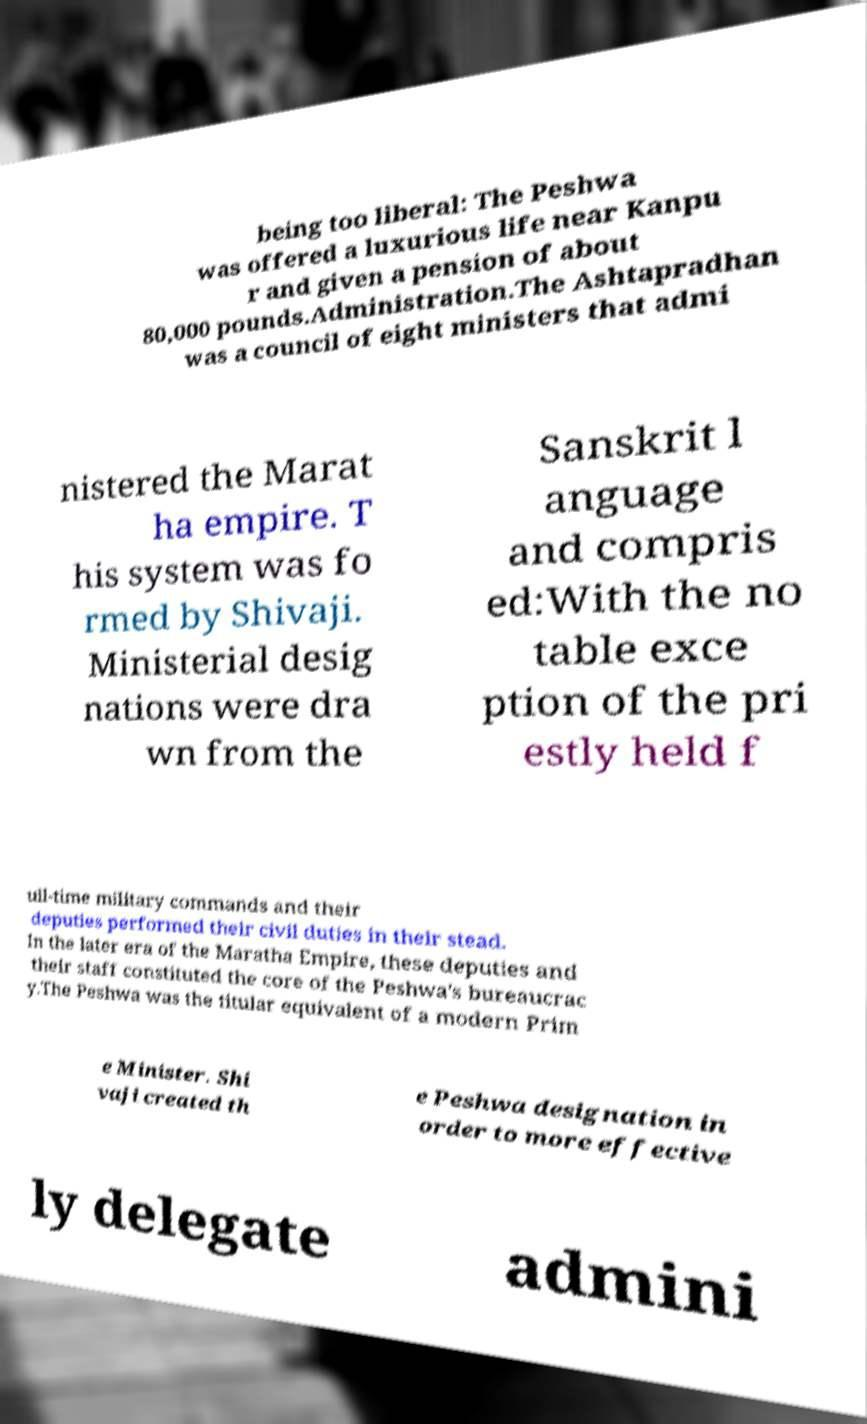I need the written content from this picture converted into text. Can you do that? being too liberal: The Peshwa was offered a luxurious life near Kanpu r and given a pension of about 80,000 pounds.Administration.The Ashtapradhan was a council of eight ministers that admi nistered the Marat ha empire. T his system was fo rmed by Shivaji. Ministerial desig nations were dra wn from the Sanskrit l anguage and compris ed:With the no table exce ption of the pri estly held f ull-time military commands and their deputies performed their civil duties in their stead. In the later era of the Maratha Empire, these deputies and their staff constituted the core of the Peshwa's bureaucrac y.The Peshwa was the titular equivalent of a modern Prim e Minister. Shi vaji created th e Peshwa designation in order to more effective ly delegate admini 